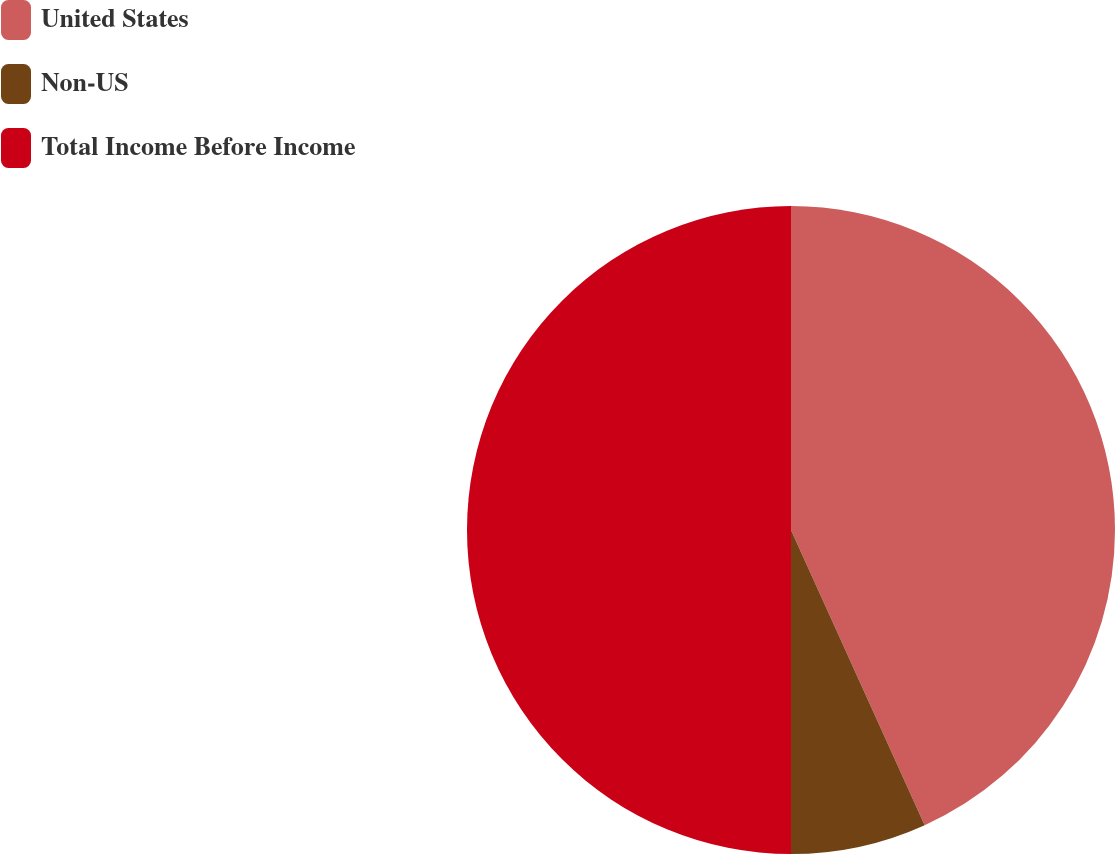Convert chart. <chart><loc_0><loc_0><loc_500><loc_500><pie_chart><fcel>United States<fcel>Non-US<fcel>Total Income Before Income<nl><fcel>43.23%<fcel>6.77%<fcel>50.0%<nl></chart> 